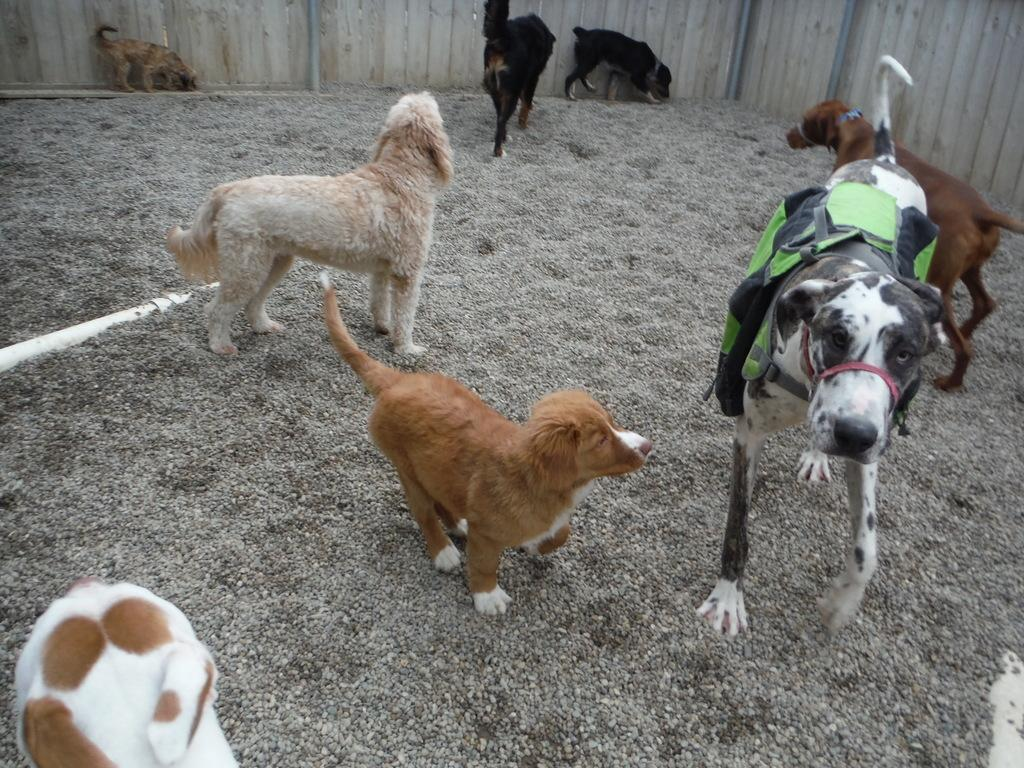What animals are present in the image? There are dogs in the image. What is the surface that the dogs are standing on? The dogs are standing on the ground. What type of material covers the ground? There are small stones on the ground. What object can be seen on the ground besides the dogs? There is a white pipe on the ground. What can be seen in the background of the image? There is a wooden wall in the background of the image. What type of writing can be seen on the dogs' collars in the image? There is no writing visible on the dogs' collars in the image. What material is the toothbrush made of that is being used by the dogs in the image? There are no toothbrushes present in the image. 